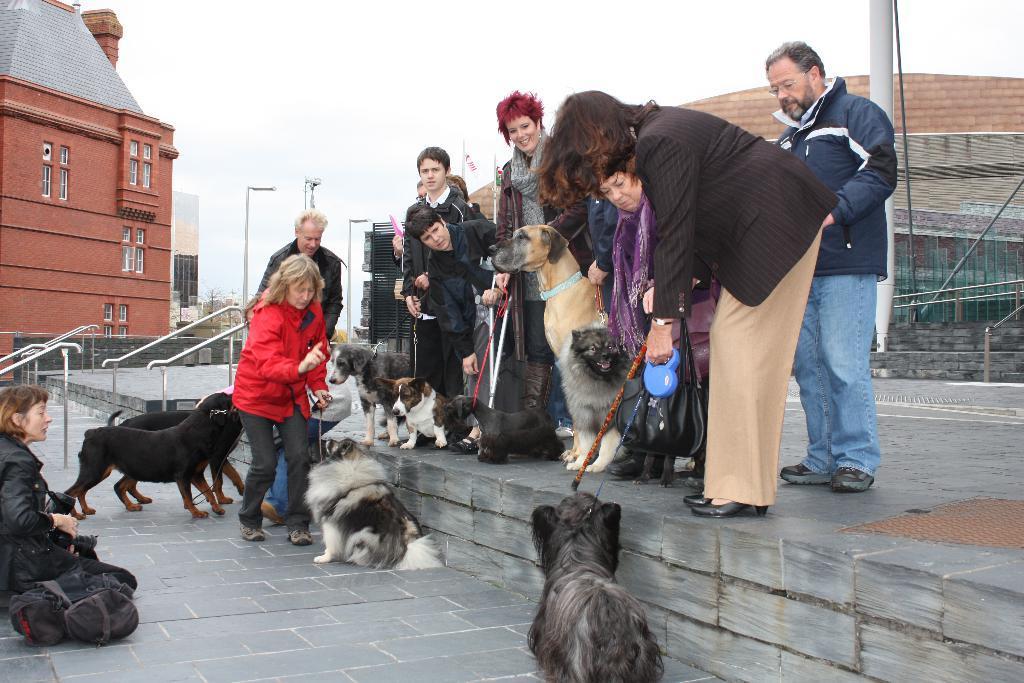How would you summarize this image in a sentence or two? In this picture we can see a group of people and dogs where this persons are holding the dogs and here woman watching them and in background we can see building with windows, sky, , pole, tees, brick wall. 